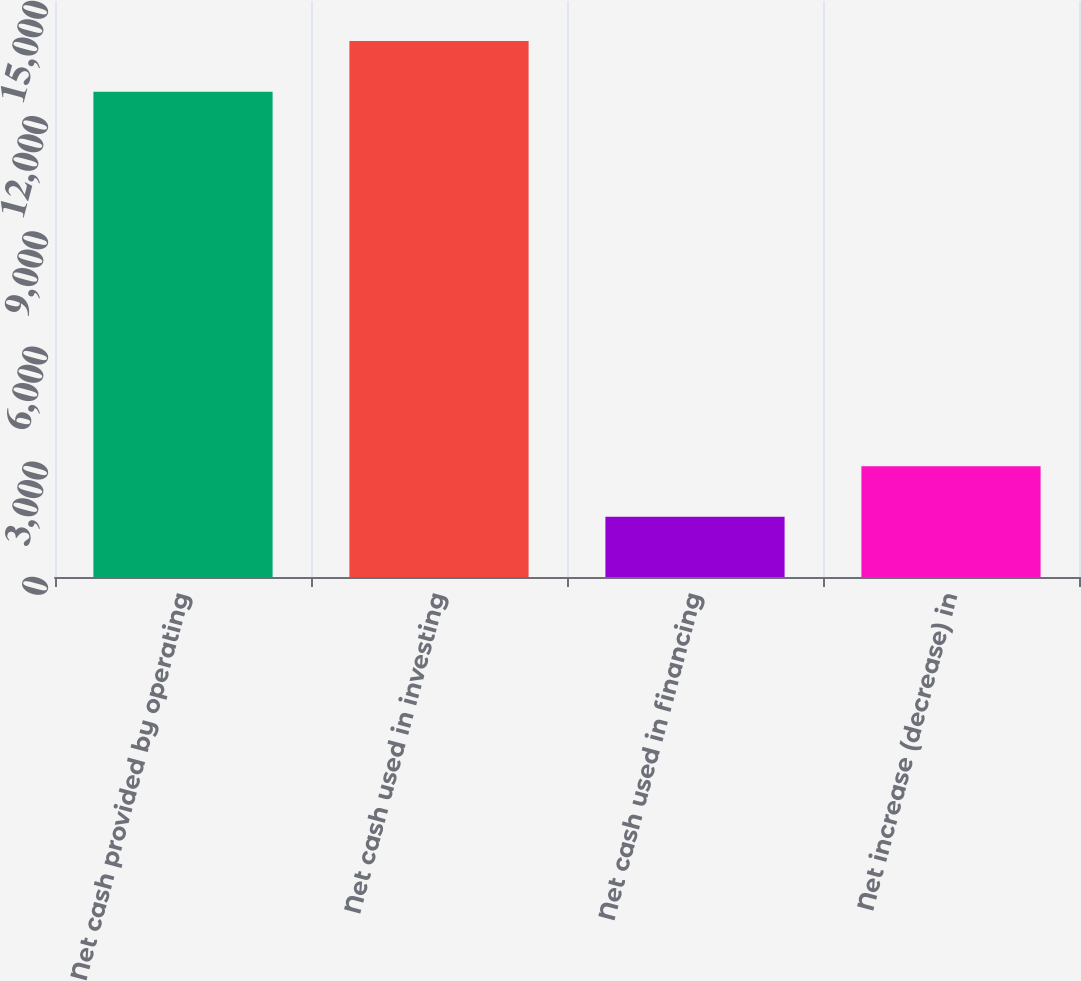Convert chart. <chart><loc_0><loc_0><loc_500><loc_500><bar_chart><fcel>Net cash provided by operating<fcel>Net cash used in investing<fcel>Net cash used in financing<fcel>Net increase (decrease) in<nl><fcel>12639<fcel>13959<fcel>1566<fcel>2886<nl></chart> 